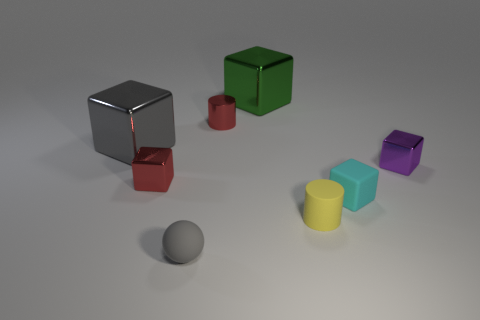Add 2 tiny metallic objects. How many objects exist? 10 Subtract all large green metal cubes. How many cubes are left? 4 Subtract all purple blocks. How many blocks are left? 4 Subtract all blue spheres. Subtract all blue cylinders. How many spheres are left? 1 Subtract all gray cubes. How many red cylinders are left? 1 Subtract all big objects. Subtract all red cylinders. How many objects are left? 5 Add 6 matte things. How many matte things are left? 9 Add 3 yellow matte balls. How many yellow matte balls exist? 3 Subtract 1 green cubes. How many objects are left? 7 Subtract all cubes. How many objects are left? 3 